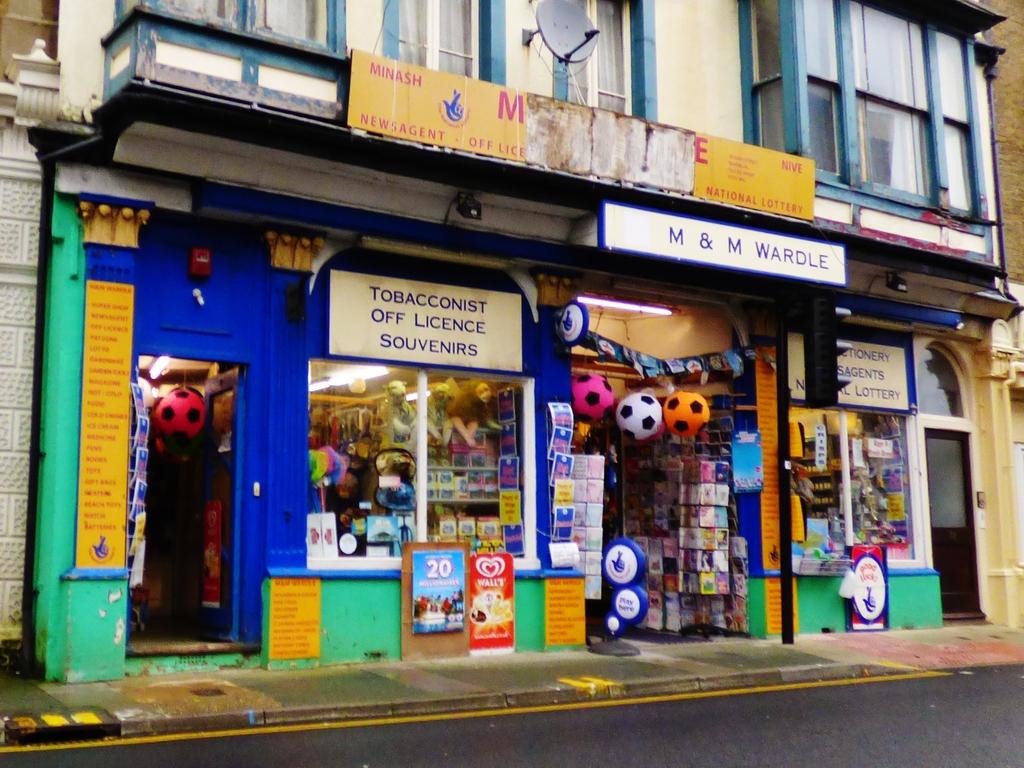What does this shop sell?
Provide a short and direct response. Tobacco. What is the name of the store?
Your response must be concise. M&m wardle. 